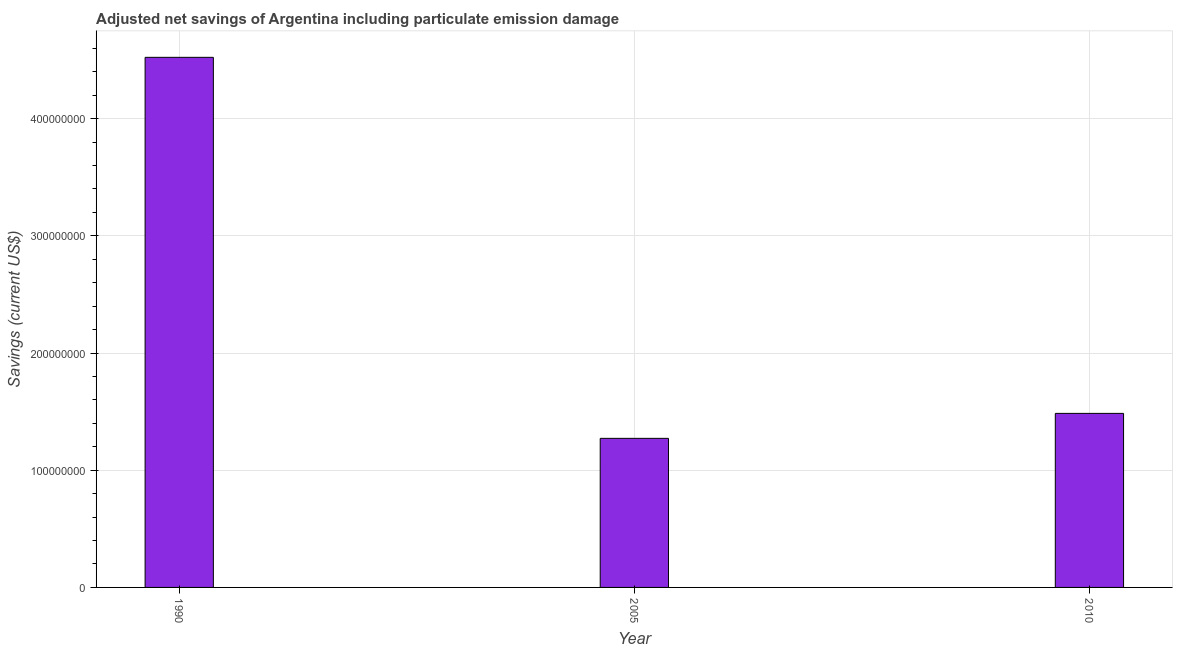What is the title of the graph?
Make the answer very short. Adjusted net savings of Argentina including particulate emission damage. What is the label or title of the X-axis?
Ensure brevity in your answer.  Year. What is the label or title of the Y-axis?
Ensure brevity in your answer.  Savings (current US$). What is the adjusted net savings in 2005?
Give a very brief answer. 1.27e+08. Across all years, what is the maximum adjusted net savings?
Your response must be concise. 4.52e+08. Across all years, what is the minimum adjusted net savings?
Provide a short and direct response. 1.27e+08. In which year was the adjusted net savings maximum?
Offer a terse response. 1990. In which year was the adjusted net savings minimum?
Provide a succinct answer. 2005. What is the sum of the adjusted net savings?
Provide a succinct answer. 7.28e+08. What is the difference between the adjusted net savings in 1990 and 2005?
Keep it short and to the point. 3.25e+08. What is the average adjusted net savings per year?
Ensure brevity in your answer.  2.43e+08. What is the median adjusted net savings?
Your answer should be compact. 1.49e+08. Do a majority of the years between 1990 and 2005 (inclusive) have adjusted net savings greater than 20000000 US$?
Your response must be concise. Yes. What is the ratio of the adjusted net savings in 2005 to that in 2010?
Your answer should be compact. 0.86. What is the difference between the highest and the second highest adjusted net savings?
Make the answer very short. 3.04e+08. Is the sum of the adjusted net savings in 1990 and 2005 greater than the maximum adjusted net savings across all years?
Keep it short and to the point. Yes. What is the difference between the highest and the lowest adjusted net savings?
Your response must be concise. 3.25e+08. How many years are there in the graph?
Make the answer very short. 3. What is the Savings (current US$) of 1990?
Offer a very short reply. 4.52e+08. What is the Savings (current US$) in 2005?
Your response must be concise. 1.27e+08. What is the Savings (current US$) of 2010?
Your answer should be compact. 1.49e+08. What is the difference between the Savings (current US$) in 1990 and 2005?
Your response must be concise. 3.25e+08. What is the difference between the Savings (current US$) in 1990 and 2010?
Your answer should be compact. 3.04e+08. What is the difference between the Savings (current US$) in 2005 and 2010?
Your answer should be compact. -2.13e+07. What is the ratio of the Savings (current US$) in 1990 to that in 2005?
Offer a terse response. 3.56. What is the ratio of the Savings (current US$) in 1990 to that in 2010?
Your answer should be very brief. 3.05. What is the ratio of the Savings (current US$) in 2005 to that in 2010?
Your response must be concise. 0.86. 